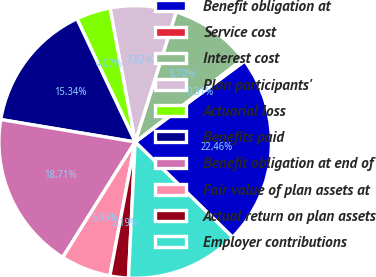Convert chart to OTSL. <chart><loc_0><loc_0><loc_500><loc_500><pie_chart><fcel>Benefit obligation at<fcel>Service cost<fcel>Interest cost<fcel>Plan participants'<fcel>Actuarial loss<fcel>Benefits paid<fcel>Benefit obligation at end of<fcel>Fair value of plan assets at<fcel>Actual return on plan assets<fcel>Employer contributions<nl><fcel>22.46%<fcel>0.31%<fcel>9.7%<fcel>7.82%<fcel>4.07%<fcel>15.34%<fcel>18.71%<fcel>5.95%<fcel>2.19%<fcel>13.46%<nl></chart> 